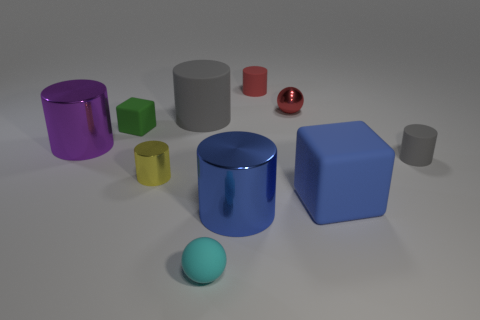Is the cyan thing made of the same material as the small yellow cylinder?
Your answer should be very brief. No. There is another cylinder that is the same color as the large matte cylinder; what is its size?
Ensure brevity in your answer.  Small. What number of small cylinders are on the left side of the cube in front of the purple metallic cylinder?
Offer a very short reply. 2. What number of cylinders are in front of the red matte object and right of the purple object?
Your response must be concise. 4. What number of objects are tiny gray things or big metal cylinders that are to the right of the tiny cyan thing?
Offer a terse response. 2. There is a red thing that is made of the same material as the cyan object; what size is it?
Give a very brief answer. Small. The big rubber thing that is to the right of the large blue metal thing on the right side of the purple metallic cylinder is what shape?
Your response must be concise. Cube. What number of green things are big rubber blocks or small things?
Offer a terse response. 1. There is a purple object left of the small ball to the right of the small red matte object; is there a ball that is behind it?
Ensure brevity in your answer.  Yes. What number of tiny objects are either yellow metallic objects or purple metal things?
Provide a succinct answer. 1. 